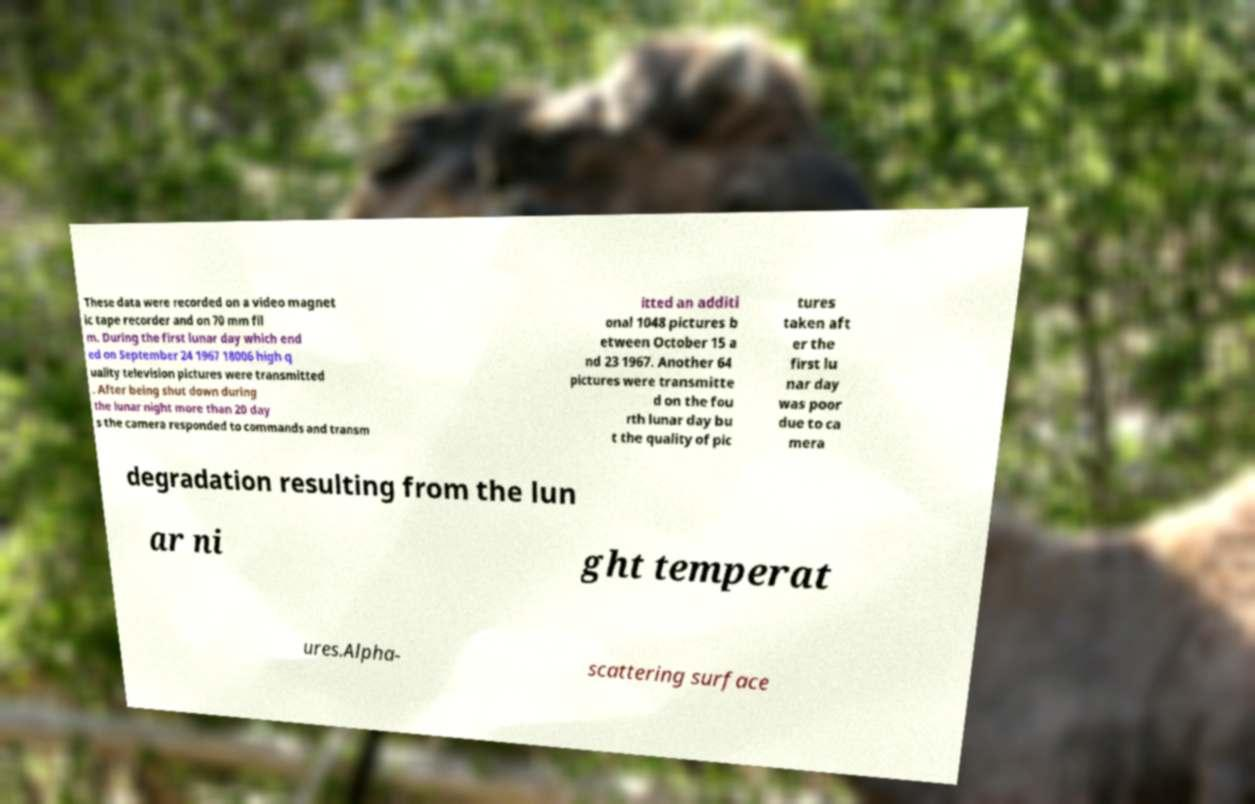There's text embedded in this image that I need extracted. Can you transcribe it verbatim? These data were recorded on a video magnet ic tape recorder and on 70 mm fil m. During the first lunar day which end ed on September 24 1967 18006 high q uality television pictures were transmitted . After being shut down during the lunar night more than 20 day s the camera responded to commands and transm itted an additi onal 1048 pictures b etween October 15 a nd 23 1967. Another 64 pictures were transmitte d on the fou rth lunar day bu t the quality of pic tures taken aft er the first lu nar day was poor due to ca mera degradation resulting from the lun ar ni ght temperat ures.Alpha- scattering surface 